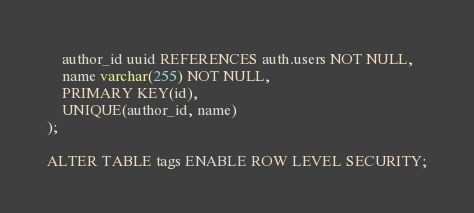Convert code to text. <code><loc_0><loc_0><loc_500><loc_500><_SQL_>    author_id uuid REFERENCES auth.users NOT NULL,
    name varchar(255) NOT NULL,
    PRIMARY KEY(id),
    UNIQUE(author_id, name)
);

ALTER TABLE tags ENABLE ROW LEVEL SECURITY;
</code> 